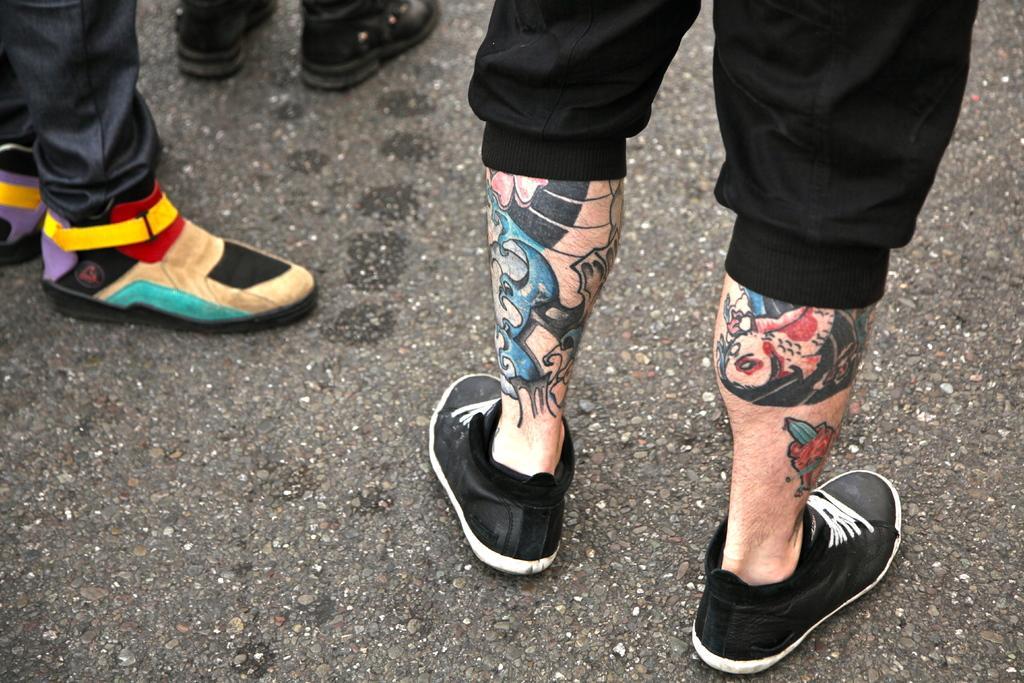Please provide a concise description of this image. In this picture we can see legs of three persons, these three persons are wearing shoes, at the bottom there is road. 